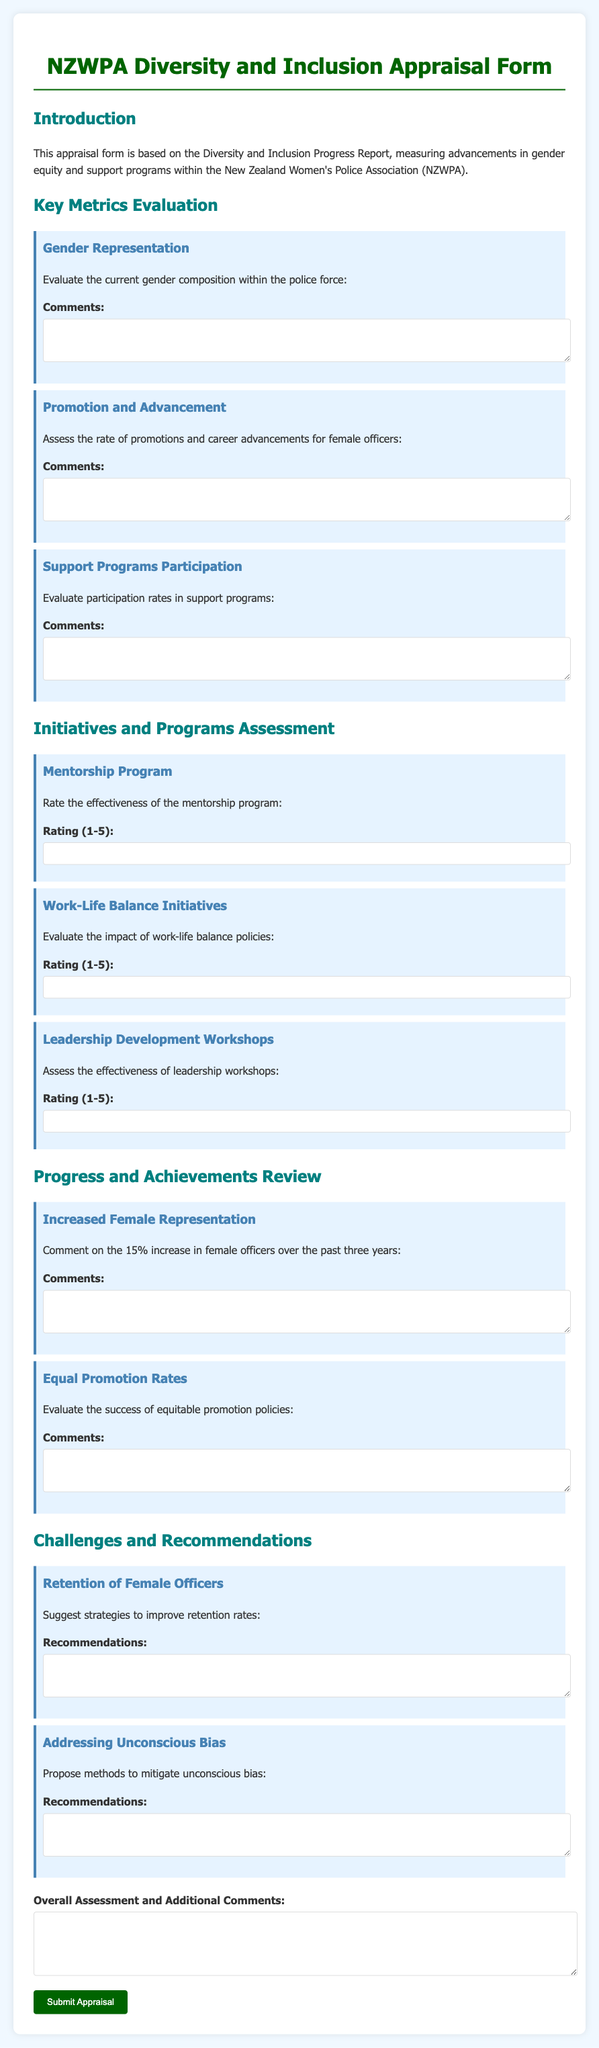What is the title of the appraisal form? The title is stated at the top of the document.
Answer: NZWPA Diversity and Inclusion Appraisal Form What topic does the introduction section cover? The introduction explains what the appraisal form is based on.
Answer: Diversity and Inclusion Progress Report What percentage increase of female officers is noted in the achievements section? The percentage is mentioned alongside the achievement related to female representation.
Answer: 15% How many rating questions are there related to initiatives and programs? The document lists the initiatives and asks for ratings.
Answer: 3 Which program's effectiveness is rated alongside mentorship? The document groups specific programs under initiatives for assessment.
Answer: Work-Life Balance Initiatives What is one of the challenges addressed in the document? The challenges section contains specific challenges faced by the department.
Answer: Retention of Female Officers What type of feedback is requested for the overall assessment? The document includes an area for final thoughts and evaluations.
Answer: Additional Comments What is the color of the border on the metrics section? The color is related to the visual styling in the document.
Answer: Dark blue 